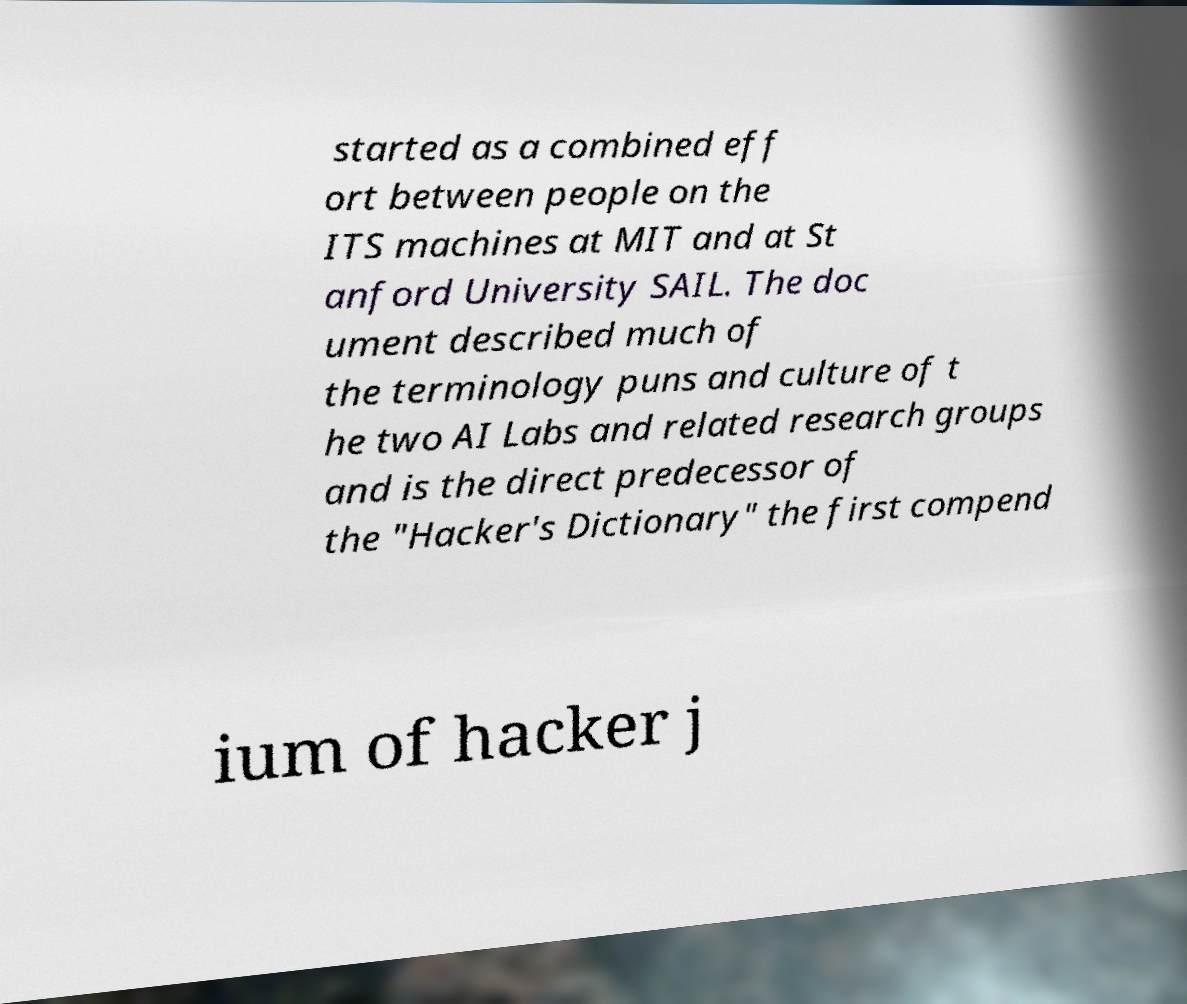Please identify and transcribe the text found in this image. started as a combined eff ort between people on the ITS machines at MIT and at St anford University SAIL. The doc ument described much of the terminology puns and culture of t he two AI Labs and related research groups and is the direct predecessor of the "Hacker's Dictionary" the first compend ium of hacker j 